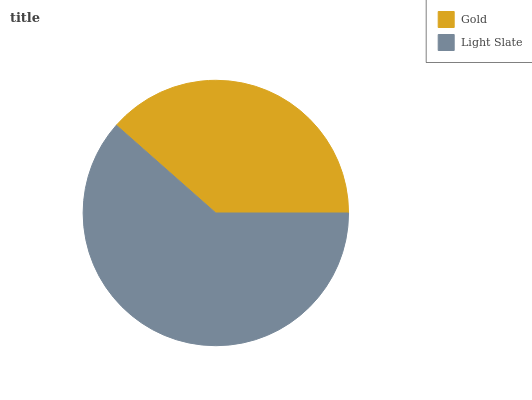Is Gold the minimum?
Answer yes or no. Yes. Is Light Slate the maximum?
Answer yes or no. Yes. Is Light Slate the minimum?
Answer yes or no. No. Is Light Slate greater than Gold?
Answer yes or no. Yes. Is Gold less than Light Slate?
Answer yes or no. Yes. Is Gold greater than Light Slate?
Answer yes or no. No. Is Light Slate less than Gold?
Answer yes or no. No. Is Light Slate the high median?
Answer yes or no. Yes. Is Gold the low median?
Answer yes or no. Yes. Is Gold the high median?
Answer yes or no. No. Is Light Slate the low median?
Answer yes or no. No. 